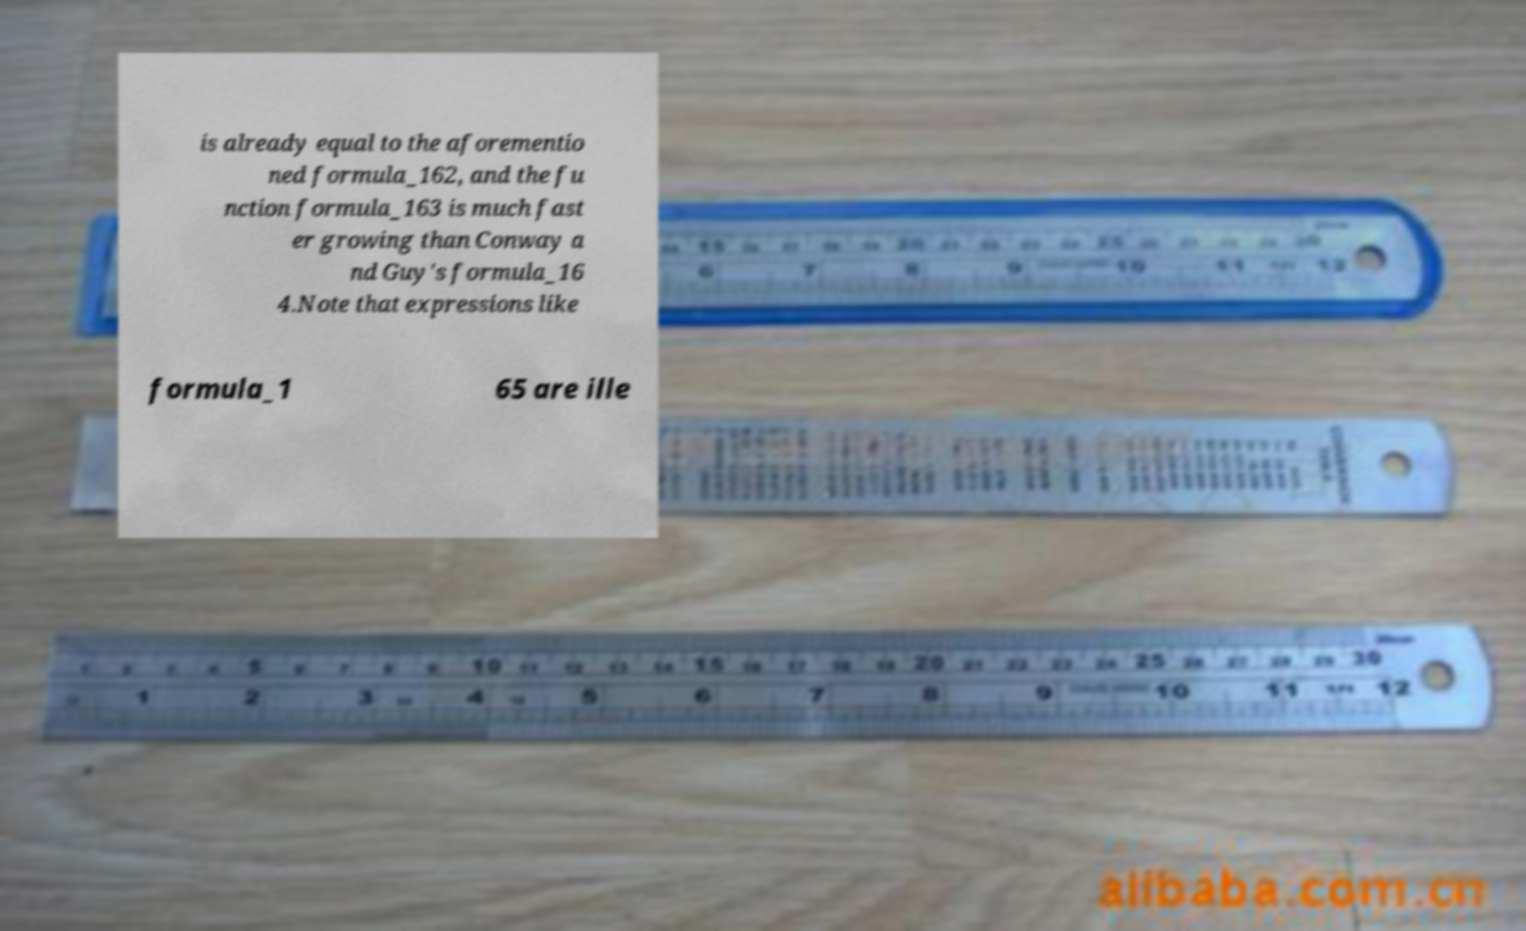Can you accurately transcribe the text from the provided image for me? is already equal to the aforementio ned formula_162, and the fu nction formula_163 is much fast er growing than Conway a nd Guy's formula_16 4.Note that expressions like formula_1 65 are ille 